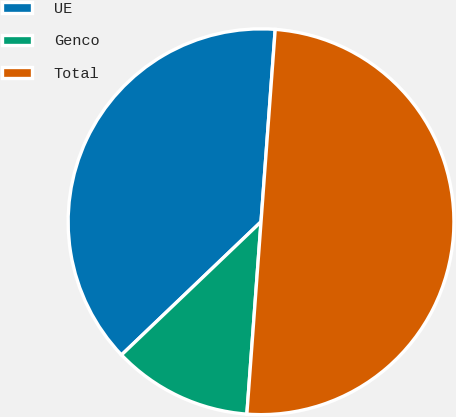Convert chart to OTSL. <chart><loc_0><loc_0><loc_500><loc_500><pie_chart><fcel>UE<fcel>Genco<fcel>Total<nl><fcel>38.3%<fcel>11.7%<fcel>50.0%<nl></chart> 